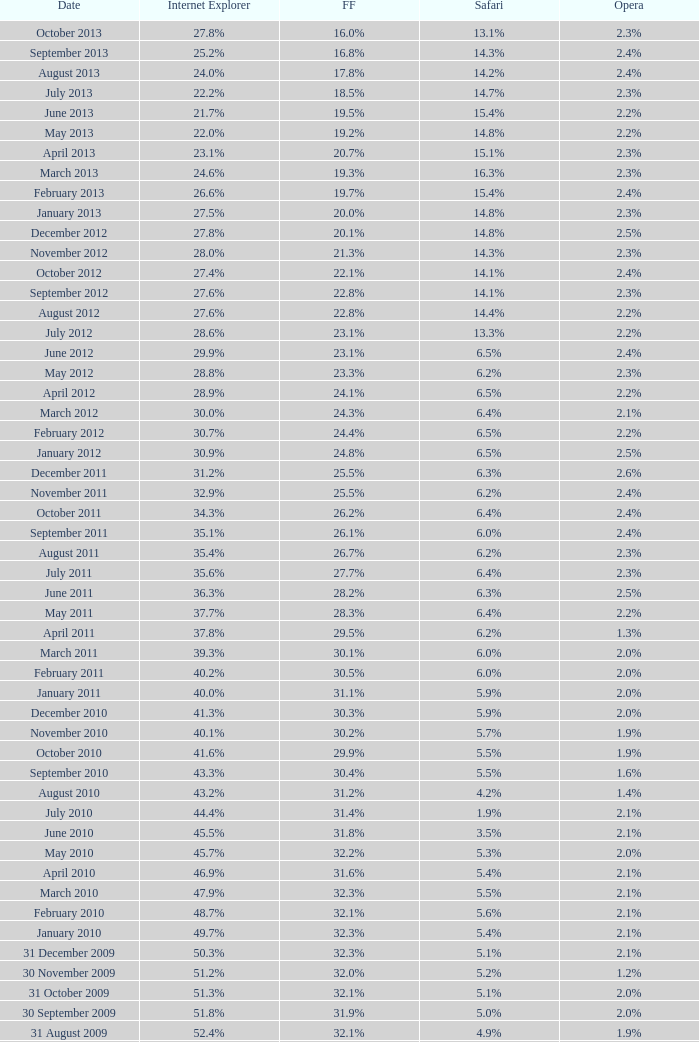Could you help me parse every detail presented in this table? {'header': ['Date', 'Internet Explorer', 'FF', 'Safari', 'Opera'], 'rows': [['October 2013', '27.8%', '16.0%', '13.1%', '2.3%'], ['September 2013', '25.2%', '16.8%', '14.3%', '2.4%'], ['August 2013', '24.0%', '17.8%', '14.2%', '2.4%'], ['July 2013', '22.2%', '18.5%', '14.7%', '2.3%'], ['June 2013', '21.7%', '19.5%', '15.4%', '2.2%'], ['May 2013', '22.0%', '19.2%', '14.8%', '2.2%'], ['April 2013', '23.1%', '20.7%', '15.1%', '2.3%'], ['March 2013', '24.6%', '19.3%', '16.3%', '2.3%'], ['February 2013', '26.6%', '19.7%', '15.4%', '2.4%'], ['January 2013', '27.5%', '20.0%', '14.8%', '2.3%'], ['December 2012', '27.8%', '20.1%', '14.8%', '2.5%'], ['November 2012', '28.0%', '21.3%', '14.3%', '2.3%'], ['October 2012', '27.4%', '22.1%', '14.1%', '2.4%'], ['September 2012', '27.6%', '22.8%', '14.1%', '2.3%'], ['August 2012', '27.6%', '22.8%', '14.4%', '2.2%'], ['July 2012', '28.6%', '23.1%', '13.3%', '2.2%'], ['June 2012', '29.9%', '23.1%', '6.5%', '2.4%'], ['May 2012', '28.8%', '23.3%', '6.2%', '2.3%'], ['April 2012', '28.9%', '24.1%', '6.5%', '2.2%'], ['March 2012', '30.0%', '24.3%', '6.4%', '2.1%'], ['February 2012', '30.7%', '24.4%', '6.5%', '2.2%'], ['January 2012', '30.9%', '24.8%', '6.5%', '2.5%'], ['December 2011', '31.2%', '25.5%', '6.3%', '2.6%'], ['November 2011', '32.9%', '25.5%', '6.2%', '2.4%'], ['October 2011', '34.3%', '26.2%', '6.4%', '2.4%'], ['September 2011', '35.1%', '26.1%', '6.0%', '2.4%'], ['August 2011', '35.4%', '26.7%', '6.2%', '2.3%'], ['July 2011', '35.6%', '27.7%', '6.4%', '2.3%'], ['June 2011', '36.3%', '28.2%', '6.3%', '2.5%'], ['May 2011', '37.7%', '28.3%', '6.4%', '2.2%'], ['April 2011', '37.8%', '29.5%', '6.2%', '1.3%'], ['March 2011', '39.3%', '30.1%', '6.0%', '2.0%'], ['February 2011', '40.2%', '30.5%', '6.0%', '2.0%'], ['January 2011', '40.0%', '31.1%', '5.9%', '2.0%'], ['December 2010', '41.3%', '30.3%', '5.9%', '2.0%'], ['November 2010', '40.1%', '30.2%', '5.7%', '1.9%'], ['October 2010', '41.6%', '29.9%', '5.5%', '1.9%'], ['September 2010', '43.3%', '30.4%', '5.5%', '1.6%'], ['August 2010', '43.2%', '31.2%', '4.2%', '1.4%'], ['July 2010', '44.4%', '31.4%', '1.9%', '2.1%'], ['June 2010', '45.5%', '31.8%', '3.5%', '2.1%'], ['May 2010', '45.7%', '32.2%', '5.3%', '2.0%'], ['April 2010', '46.9%', '31.6%', '5.4%', '2.1%'], ['March 2010', '47.9%', '32.3%', '5.5%', '2.1%'], ['February 2010', '48.7%', '32.1%', '5.6%', '2.1%'], ['January 2010', '49.7%', '32.3%', '5.4%', '2.1%'], ['31 December 2009', '50.3%', '32.3%', '5.1%', '2.1%'], ['30 November 2009', '51.2%', '32.0%', '5.2%', '1.2%'], ['31 October 2009', '51.3%', '32.1%', '5.1%', '2.0%'], ['30 September 2009', '51.8%', '31.9%', '5.0%', '2.0%'], ['31 August 2009', '52.4%', '32.1%', '4.9%', '1.9%'], ['31 July 2009', '53.1%', '31.7%', '4.6%', '1.8%'], ['30 June 2009', '57.1%', '31.6%', '3.2%', '2.0%'], ['31 May 2009', '57.5%', '31.4%', '3.1%', '2.0%'], ['30 April 2009', '57.6%', '31.6%', '2.9%', '2.0%'], ['31 March 2009', '57.8%', '31.5%', '2.8%', '2.0%'], ['28 February 2009', '58.1%', '31.3%', '2.7%', '2.0%'], ['31 January 2009', '58.4%', '31.1%', '2.7%', '2.0%'], ['31 December 2008', '58.6%', '31.1%', '2.9%', '2.1%'], ['30 November 2008', '59.0%', '30.8%', '3.0%', '2.0%'], ['31 October 2008', '59.4%', '30.6%', '3.0%', '2.0%'], ['30 September 2008', '57.3%', '32.5%', '2.7%', '2.0%'], ['31 August 2008', '58.7%', '31.4%', '2.4%', '2.1%'], ['31 July 2008', '60.9%', '29.7%', '2.4%', '2.0%'], ['30 June 2008', '61.7%', '29.1%', '2.5%', '2.0%'], ['31 May 2008', '61.9%', '28.9%', '2.7%', '2.0%'], ['30 April 2008', '62.0%', '28.8%', '2.8%', '2.0%'], ['31 March 2008', '62.0%', '28.8%', '2.8%', '2.0%'], ['29 February 2008', '62.0%', '28.7%', '2.8%', '2.0%'], ['31 January 2008', '62.2%', '28.7%', '2.7%', '2.0%'], ['1 December 2007', '62.8%', '28.0%', '2.6%', '2.0%'], ['10 November 2007', '63.0%', '27.8%', '2.5%', '2.0%'], ['30 October 2007', '65.5%', '26.3%', '2.3%', '1.8%'], ['20 September 2007', '66.6%', '25.6%', '2.1%', '1.8%'], ['30 August 2007', '66.7%', '25.5%', '2.1%', '1.8%'], ['30 July 2007', '66.9%', '25.1%', '2.2%', '1.8%'], ['30 June 2007', '66.9%', '25.1%', '2.3%', '1.8%'], ['30 May 2007', '67.1%', '24.8%', '2.4%', '1.8%'], ['Date', 'Internet Explorer', 'Firefox', 'Safari', 'Opera']]} 9% safari? 31.4%. 